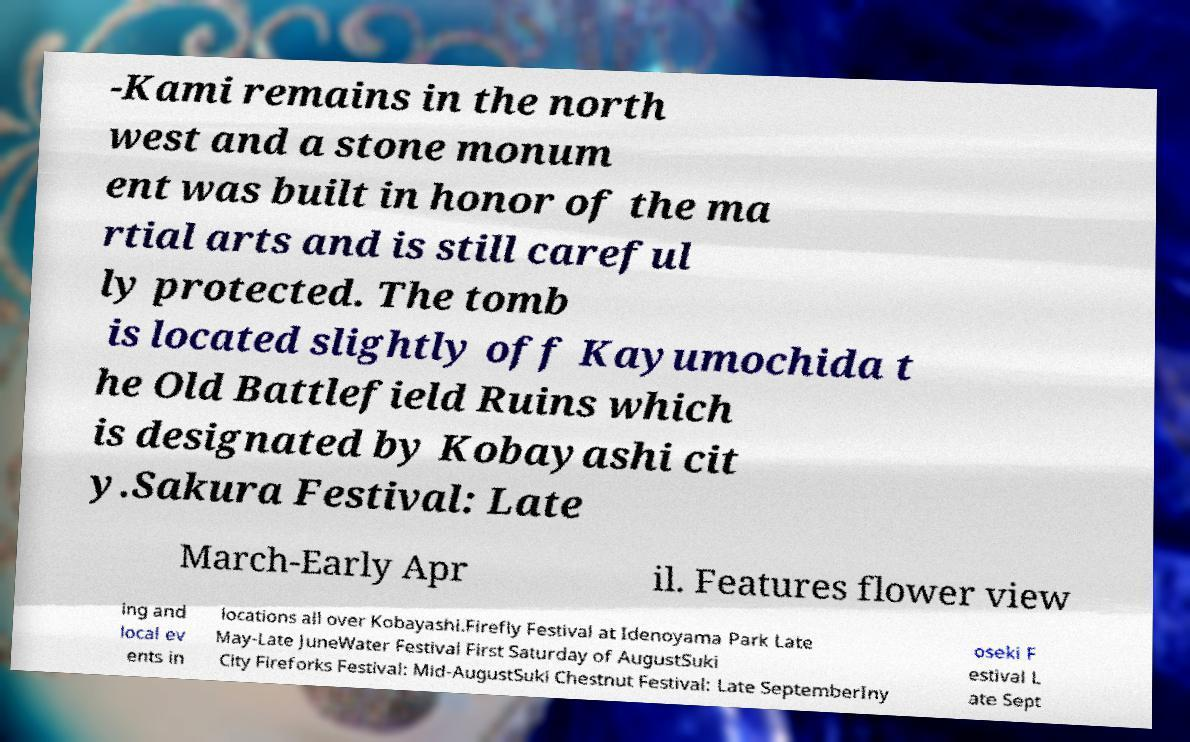Please read and relay the text visible in this image. What does it say? -Kami remains in the north west and a stone monum ent was built in honor of the ma rtial arts and is still careful ly protected. The tomb is located slightly off Kayumochida t he Old Battlefield Ruins which is designated by Kobayashi cit y.Sakura Festival: Late March-Early Apr il. Features flower view ing and local ev ents in locations all over Kobayashi.Firefly Festival at Idenoyama Park Late May-Late JuneWater Festival First Saturday of AugustSuki City Fireforks Festival: Mid-AugustSuki Chestnut Festival: Late SeptemberIny oseki F estival L ate Sept 